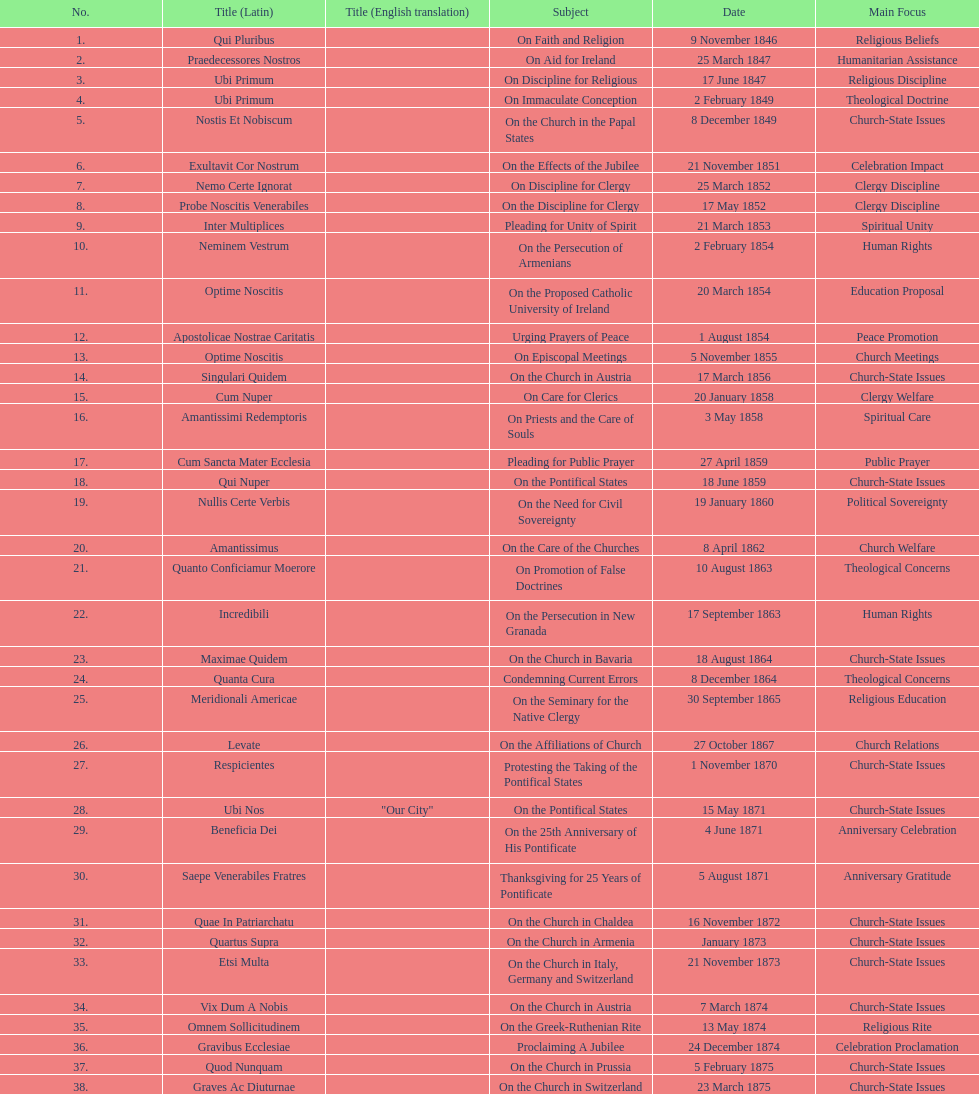Parse the table in full. {'header': ['No.', 'Title (Latin)', 'Title (English translation)', 'Subject', 'Date', 'Main Focus'], 'rows': [['1.', 'Qui Pluribus', '', 'On Faith and Religion', '9 November 1846', 'Religious Beliefs'], ['2.', 'Praedecessores Nostros', '', 'On Aid for Ireland', '25 March 1847', 'Humanitarian Assistance'], ['3.', 'Ubi Primum', '', 'On Discipline for Religious', '17 June 1847', 'Religious Discipline'], ['4.', 'Ubi Primum', '', 'On Immaculate Conception', '2 February 1849', 'Theological Doctrine'], ['5.', 'Nostis Et Nobiscum', '', 'On the Church in the Papal States', '8 December 1849', 'Church-State Issues'], ['6.', 'Exultavit Cor Nostrum', '', 'On the Effects of the Jubilee', '21 November 1851', 'Celebration Impact'], ['7.', 'Nemo Certe Ignorat', '', 'On Discipline for Clergy', '25 March 1852', 'Clergy Discipline'], ['8.', 'Probe Noscitis Venerabiles', '', 'On the Discipline for Clergy', '17 May 1852', 'Clergy Discipline'], ['9.', 'Inter Multiplices', '', 'Pleading for Unity of Spirit', '21 March 1853', 'Spiritual Unity'], ['10.', 'Neminem Vestrum', '', 'On the Persecution of Armenians', '2 February 1854', 'Human Rights'], ['11.', 'Optime Noscitis', '', 'On the Proposed Catholic University of Ireland', '20 March 1854', 'Education Proposal'], ['12.', 'Apostolicae Nostrae Caritatis', '', 'Urging Prayers of Peace', '1 August 1854', 'Peace Promotion'], ['13.', 'Optime Noscitis', '', 'On Episcopal Meetings', '5 November 1855', 'Church Meetings'], ['14.', 'Singulari Quidem', '', 'On the Church in Austria', '17 March 1856', 'Church-State Issues'], ['15.', 'Cum Nuper', '', 'On Care for Clerics', '20 January 1858', 'Clergy Welfare'], ['16.', 'Amantissimi Redemptoris', '', 'On Priests and the Care of Souls', '3 May 1858', 'Spiritual Care'], ['17.', 'Cum Sancta Mater Ecclesia', '', 'Pleading for Public Prayer', '27 April 1859', 'Public Prayer'], ['18.', 'Qui Nuper', '', 'On the Pontifical States', '18 June 1859', 'Church-State Issues'], ['19.', 'Nullis Certe Verbis', '', 'On the Need for Civil Sovereignty', '19 January 1860', 'Political Sovereignty'], ['20.', 'Amantissimus', '', 'On the Care of the Churches', '8 April 1862', 'Church Welfare'], ['21.', 'Quanto Conficiamur Moerore', '', 'On Promotion of False Doctrines', '10 August 1863', 'Theological Concerns'], ['22.', 'Incredibili', '', 'On the Persecution in New Granada', '17 September 1863', 'Human Rights'], ['23.', 'Maximae Quidem', '', 'On the Church in Bavaria', '18 August 1864', 'Church-State Issues'], ['24.', 'Quanta Cura', '', 'Condemning Current Errors', '8 December 1864', 'Theological Concerns'], ['25.', 'Meridionali Americae', '', 'On the Seminary for the Native Clergy', '30 September 1865', 'Religious Education'], ['26.', 'Levate', '', 'On the Affiliations of Church', '27 October 1867', 'Church Relations'], ['27.', 'Respicientes', '', 'Protesting the Taking of the Pontifical States', '1 November 1870', 'Church-State Issues'], ['28.', 'Ubi Nos', '"Our City"', 'On the Pontifical States', '15 May 1871', 'Church-State Issues'], ['29.', 'Beneficia Dei', '', 'On the 25th Anniversary of His Pontificate', '4 June 1871', 'Anniversary Celebration'], ['30.', 'Saepe Venerabiles Fratres', '', 'Thanksgiving for 25 Years of Pontificate', '5 August 1871', 'Anniversary Gratitude'], ['31.', 'Quae In Patriarchatu', '', 'On the Church in Chaldea', '16 November 1872', 'Church-State Issues'], ['32.', 'Quartus Supra', '', 'On the Church in Armenia', 'January 1873', 'Church-State Issues'], ['33.', 'Etsi Multa', '', 'On the Church in Italy, Germany and Switzerland', '21 November 1873', 'Church-State Issues'], ['34.', 'Vix Dum A Nobis', '', 'On the Church in Austria', '7 March 1874', 'Church-State Issues'], ['35.', 'Omnem Sollicitudinem', '', 'On the Greek-Ruthenian Rite', '13 May 1874', 'Religious Rite'], ['36.', 'Gravibus Ecclesiae', '', 'Proclaiming A Jubilee', '24 December 1874', 'Celebration Proclamation'], ['37.', 'Quod Nunquam', '', 'On the Church in Prussia', '5 February 1875', 'Church-State Issues'], ['38.', 'Graves Ac Diuturnae', '', 'On the Church in Switzerland', '23 March 1875', 'Church-State Issues']]} Total number of encyclicals on churches . 11. 